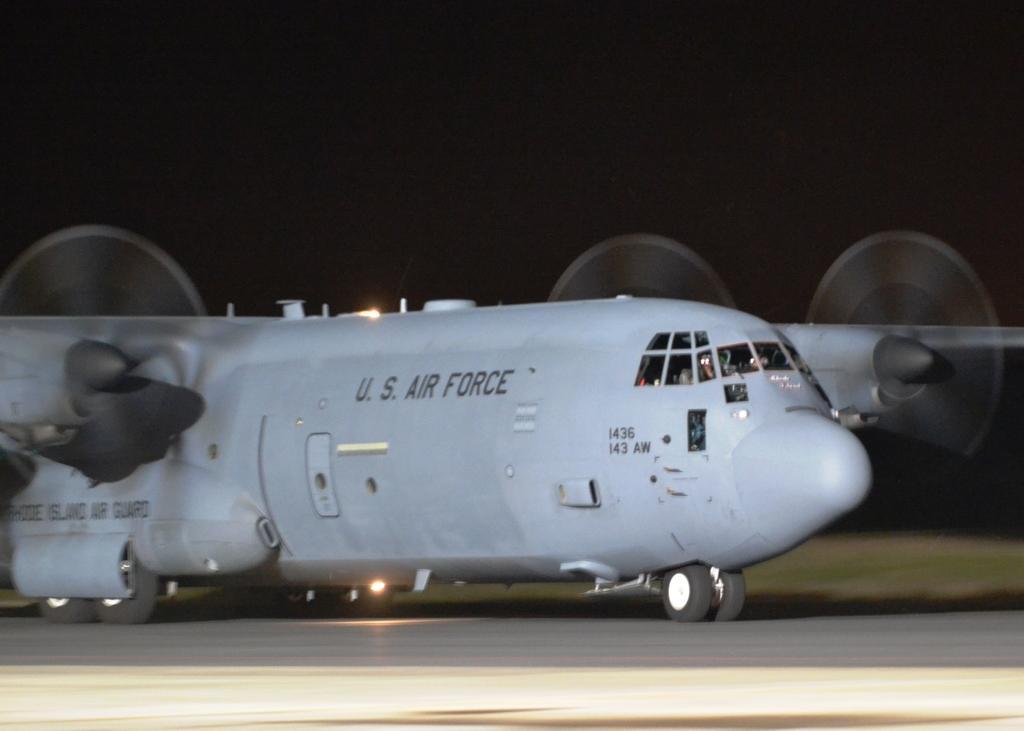Could you give a brief overview of what you see in this image? In this image, we can see an aircraft on the runway. Here we can see wheels and lights. Background there is a dark view. 